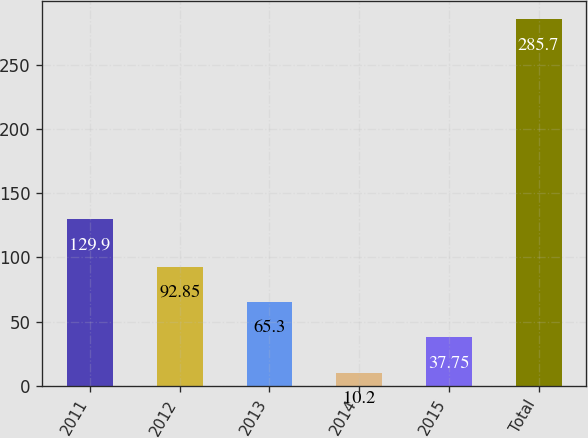<chart> <loc_0><loc_0><loc_500><loc_500><bar_chart><fcel>2011<fcel>2012<fcel>2013<fcel>2014<fcel>2015<fcel>Total<nl><fcel>129.9<fcel>92.85<fcel>65.3<fcel>10.2<fcel>37.75<fcel>285.7<nl></chart> 